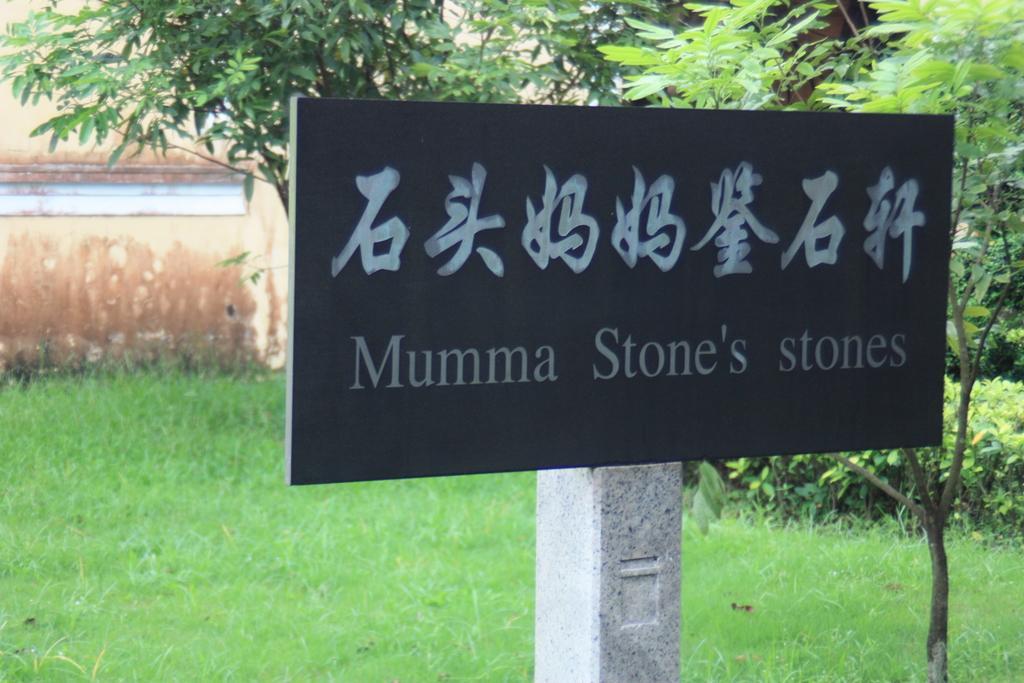Can you describe this image briefly? In this picture there is a black board which has something written on it is attached to a pole behind it and there are trees in the right corner and the ground is greenery. 